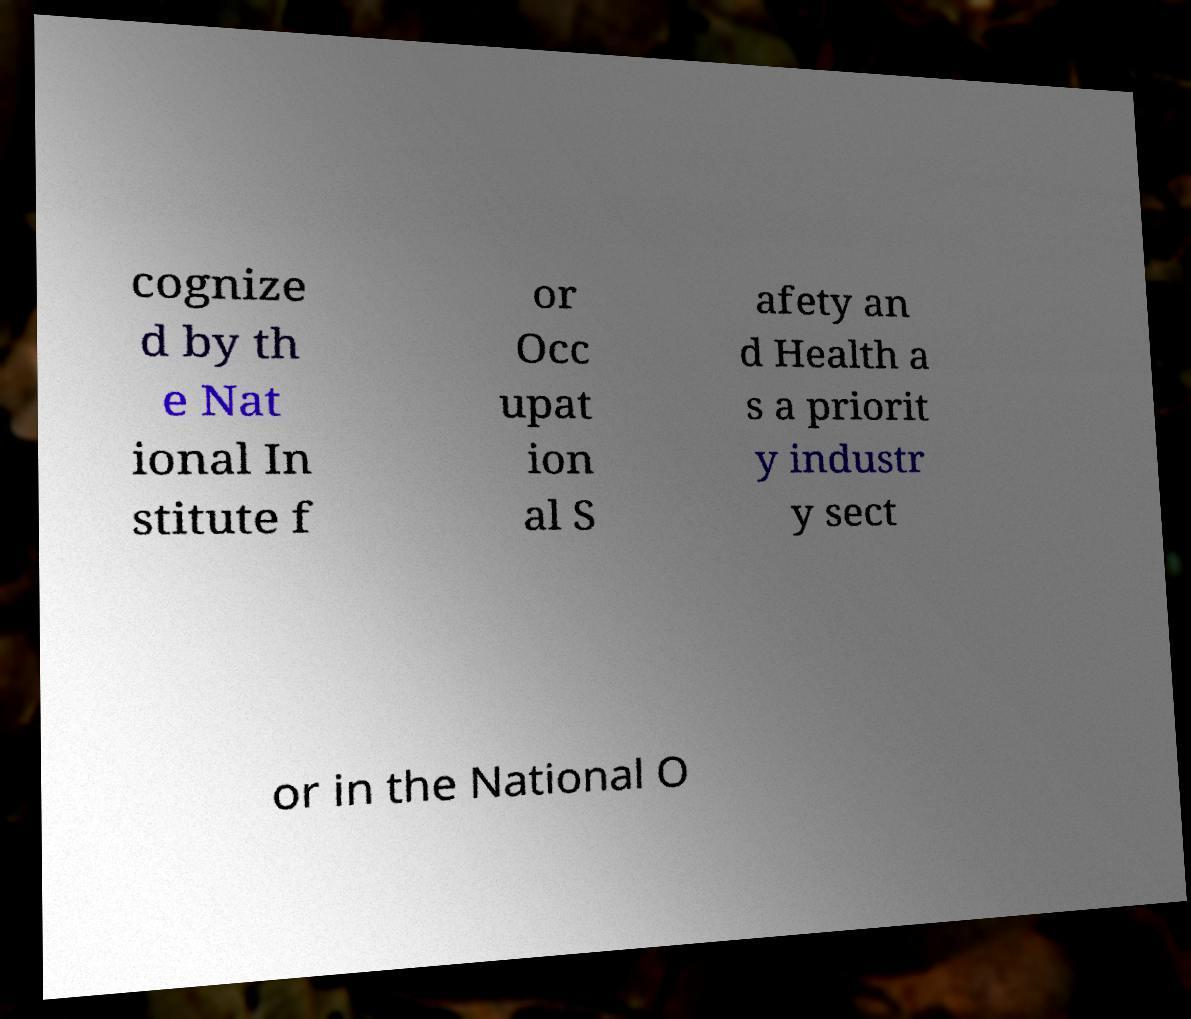Please read and relay the text visible in this image. What does it say? cognize d by th e Nat ional In stitute f or Occ upat ion al S afety an d Health a s a priorit y industr y sect or in the National O 